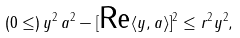Convert formula to latex. <formula><loc_0><loc_0><loc_500><loc_500>\left ( 0 \leq \right ) \| y \| ^ { 2 } \, \| a \| ^ { 2 } - [ \text {Re} \langle y , a \rangle ] ^ { 2 } \leq r ^ { 2 } \| y \| ^ { 2 } ,</formula> 